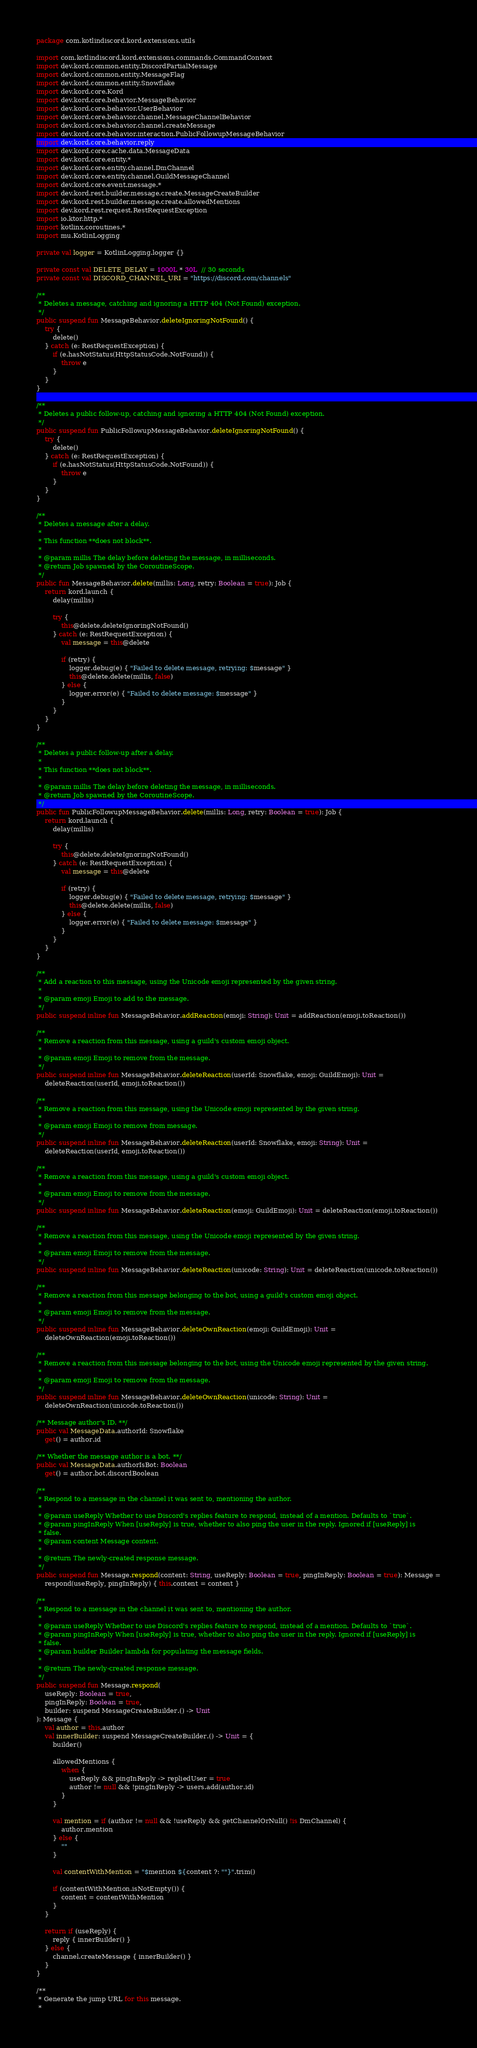Convert code to text. <code><loc_0><loc_0><loc_500><loc_500><_Kotlin_>package com.kotlindiscord.kord.extensions.utils

import com.kotlindiscord.kord.extensions.commands.CommandContext
import dev.kord.common.entity.DiscordPartialMessage
import dev.kord.common.entity.MessageFlag
import dev.kord.common.entity.Snowflake
import dev.kord.core.Kord
import dev.kord.core.behavior.MessageBehavior
import dev.kord.core.behavior.UserBehavior
import dev.kord.core.behavior.channel.MessageChannelBehavior
import dev.kord.core.behavior.channel.createMessage
import dev.kord.core.behavior.interaction.PublicFollowupMessageBehavior
import dev.kord.core.behavior.reply
import dev.kord.core.cache.data.MessageData
import dev.kord.core.entity.*
import dev.kord.core.entity.channel.DmChannel
import dev.kord.core.entity.channel.GuildMessageChannel
import dev.kord.core.event.message.*
import dev.kord.rest.builder.message.create.MessageCreateBuilder
import dev.kord.rest.builder.message.create.allowedMentions
import dev.kord.rest.request.RestRequestException
import io.ktor.http.*
import kotlinx.coroutines.*
import mu.KotlinLogging

private val logger = KotlinLogging.logger {}

private const val DELETE_DELAY = 1000L * 30L  // 30 seconds
private const val DISCORD_CHANNEL_URI = "https://discord.com/channels"

/**
 * Deletes a message, catching and ignoring a HTTP 404 (Not Found) exception.
 */
public suspend fun MessageBehavior.deleteIgnoringNotFound() {
    try {
        delete()
    } catch (e: RestRequestException) {
        if (e.hasNotStatus(HttpStatusCode.NotFound)) {
            throw e
        }
    }
}

/**
 * Deletes a public follow-up, catching and ignoring a HTTP 404 (Not Found) exception.
 */
public suspend fun PublicFollowupMessageBehavior.deleteIgnoringNotFound() {
    try {
        delete()
    } catch (e: RestRequestException) {
        if (e.hasNotStatus(HttpStatusCode.NotFound)) {
            throw e
        }
    }
}

/**
 * Deletes a message after a delay.
 *
 * This function **does not block**.
 *
 * @param millis The delay before deleting the message, in milliseconds.
 * @return Job spawned by the CoroutineScope.
 */
public fun MessageBehavior.delete(millis: Long, retry: Boolean = true): Job {
    return kord.launch {
        delay(millis)

        try {
            this@delete.deleteIgnoringNotFound()
        } catch (e: RestRequestException) {
            val message = this@delete

            if (retry) {
                logger.debug(e) { "Failed to delete message, retrying: $message" }
                this@delete.delete(millis, false)
            } else {
                logger.error(e) { "Failed to delete message: $message" }
            }
        }
    }
}

/**
 * Deletes a public follow-up after a delay.
 *
 * This function **does not block**.
 *
 * @param millis The delay before deleting the message, in milliseconds.
 * @return Job spawned by the CoroutineScope.
 */
public fun PublicFollowupMessageBehavior.delete(millis: Long, retry: Boolean = true): Job {
    return kord.launch {
        delay(millis)

        try {
            this@delete.deleteIgnoringNotFound()
        } catch (e: RestRequestException) {
            val message = this@delete

            if (retry) {
                logger.debug(e) { "Failed to delete message, retrying: $message" }
                this@delete.delete(millis, false)
            } else {
                logger.error(e) { "Failed to delete message: $message" }
            }
        }
    }
}

/**
 * Add a reaction to this message, using the Unicode emoji represented by the given string.
 *
 * @param emoji Emoji to add to the message.
 */
public suspend inline fun MessageBehavior.addReaction(emoji: String): Unit = addReaction(emoji.toReaction())

/**
 * Remove a reaction from this message, using a guild's custom emoji object.
 *
 * @param emoji Emoji to remove from the message.
 */
public suspend inline fun MessageBehavior.deleteReaction(userId: Snowflake, emoji: GuildEmoji): Unit =
    deleteReaction(userId, emoji.toReaction())

/**
 * Remove a reaction from this message, using the Unicode emoji represented by the given string.
 *
 * @param emoji Emoji to remove from message.
 */
public suspend inline fun MessageBehavior.deleteReaction(userId: Snowflake, emoji: String): Unit =
    deleteReaction(userId, emoji.toReaction())

/**
 * Remove a reaction from this message, using a guild's custom emoji object.
 *
 * @param emoji Emoji to remove from the message.
 */
public suspend inline fun MessageBehavior.deleteReaction(emoji: GuildEmoji): Unit = deleteReaction(emoji.toReaction())

/**
 * Remove a reaction from this message, using the Unicode emoji represented by the given string.
 *
 * @param emoji Emoji to remove from the message.
 */
public suspend inline fun MessageBehavior.deleteReaction(unicode: String): Unit = deleteReaction(unicode.toReaction())

/**
 * Remove a reaction from this message belonging to the bot, using a guild's custom emoji object.
 *
 * @param emoji Emoji to remove from the message.
 */
public suspend inline fun MessageBehavior.deleteOwnReaction(emoji: GuildEmoji): Unit =
    deleteOwnReaction(emoji.toReaction())

/**
 * Remove a reaction from this message belonging to the bot, using the Unicode emoji represented by the given string.
 *
 * @param emoji Emoji to remove from the message.
 */
public suspend inline fun MessageBehavior.deleteOwnReaction(unicode: String): Unit =
    deleteOwnReaction(unicode.toReaction())

/** Message author's ID. **/
public val MessageData.authorId: Snowflake
    get() = author.id

/** Whether the message author is a bot. **/
public val MessageData.authorIsBot: Boolean
    get() = author.bot.discordBoolean

/**
 * Respond to a message in the channel it was sent to, mentioning the author.
 *
 * @param useReply Whether to use Discord's replies feature to respond, instead of a mention. Defaults to `true`.
 * @param pingInReply When [useReply] is true, whether to also ping the user in the reply. Ignored if [useReply] is
 * false.
 * @param content Message content.
 *
 * @return The newly-created response message.
 */
public suspend fun Message.respond(content: String, useReply: Boolean = true, pingInReply: Boolean = true): Message =
    respond(useReply, pingInReply) { this.content = content }

/**
 * Respond to a message in the channel it was sent to, mentioning the author.
 *
 * @param useReply Whether to use Discord's replies feature to respond, instead of a mention. Defaults to `true`.
 * @param pingInReply When [useReply] is true, whether to also ping the user in the reply. Ignored if [useReply] is
 * false.
 * @param builder Builder lambda for populating the message fields.
 *
 * @return The newly-created response message.
 */
public suspend fun Message.respond(
    useReply: Boolean = true,
    pingInReply: Boolean = true,
    builder: suspend MessageCreateBuilder.() -> Unit
): Message {
    val author = this.author
    val innerBuilder: suspend MessageCreateBuilder.() -> Unit = {
        builder()

        allowedMentions {
            when {
                useReply && pingInReply -> repliedUser = true
                author != null && !pingInReply -> users.add(author.id)
            }
        }

        val mention = if (author != null && !useReply && getChannelOrNull() !is DmChannel) {
            author.mention
        } else {
            ""
        }

        val contentWithMention = "$mention ${content ?: ""}".trim()

        if (contentWithMention.isNotEmpty()) {
            content = contentWithMention
        }
    }

    return if (useReply) {
        reply { innerBuilder() }
    } else {
        channel.createMessage { innerBuilder() }
    }
}

/**
 * Generate the jump URL for this message.
 *</code> 